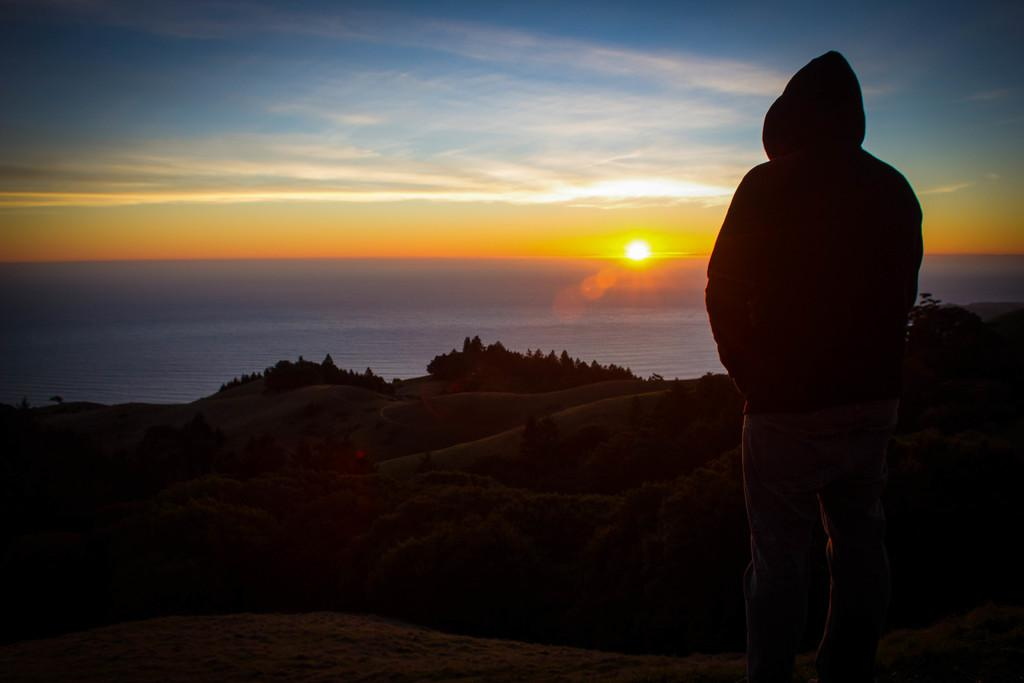What is the main subject of the image? There is a person standing in the image. What else can be seen in the image besides the person? There are plants and sand visible in the image. What is visible in the background of the image? The sky is visible in the image. Where is the faucet located in the image? There is no faucet present in the image. What type of sugar can be seen in the image? There is no sugar present in the image. 